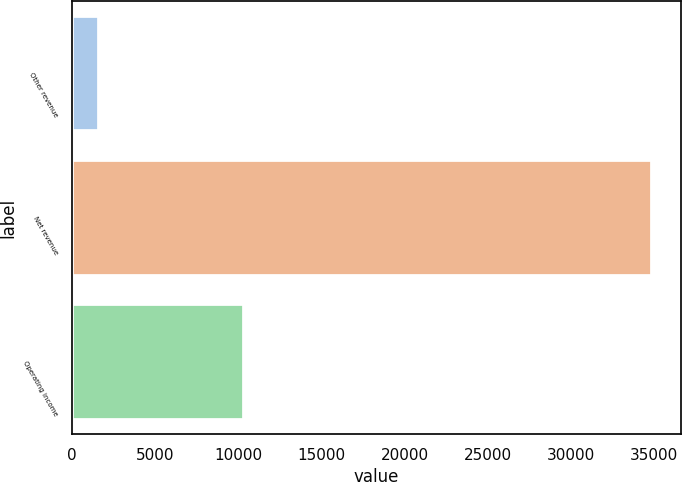Convert chart. <chart><loc_0><loc_0><loc_500><loc_500><bar_chart><fcel>Other revenue<fcel>Net revenue<fcel>Operating income<nl><fcel>1637<fcel>34872<fcel>10327<nl></chart> 